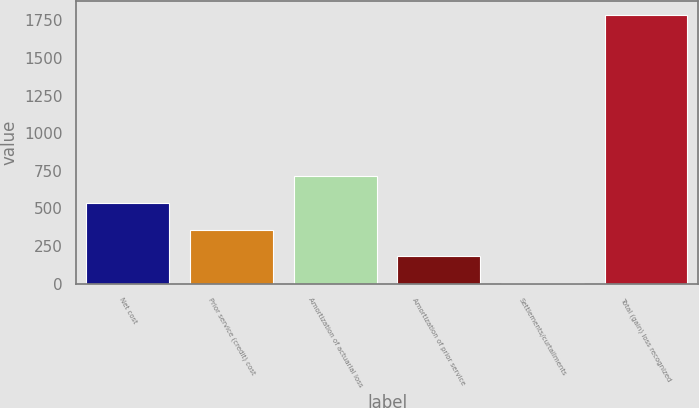Convert chart. <chart><loc_0><loc_0><loc_500><loc_500><bar_chart><fcel>Net cost<fcel>Prior service (credit) cost<fcel>Amortization of actuarial loss<fcel>Amortization of prior service<fcel>Settlements/curtailments<fcel>Total (gain) loss recognized<nl><fcel>537.2<fcel>358.8<fcel>715.6<fcel>180.4<fcel>2<fcel>1786<nl></chart> 